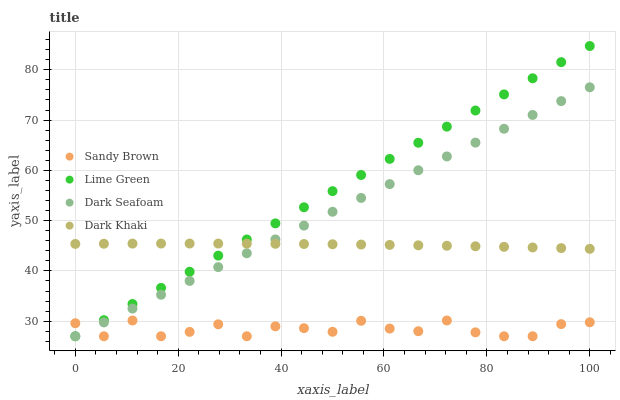Does Sandy Brown have the minimum area under the curve?
Answer yes or no. Yes. Does Lime Green have the maximum area under the curve?
Answer yes or no. Yes. Does Dark Seafoam have the minimum area under the curve?
Answer yes or no. No. Does Dark Seafoam have the maximum area under the curve?
Answer yes or no. No. Is Lime Green the smoothest?
Answer yes or no. Yes. Is Sandy Brown the roughest?
Answer yes or no. Yes. Is Dark Seafoam the smoothest?
Answer yes or no. No. Is Dark Seafoam the roughest?
Answer yes or no. No. Does Lime Green have the lowest value?
Answer yes or no. Yes. Does Lime Green have the highest value?
Answer yes or no. Yes. Does Dark Seafoam have the highest value?
Answer yes or no. No. Is Sandy Brown less than Dark Khaki?
Answer yes or no. Yes. Is Dark Khaki greater than Sandy Brown?
Answer yes or no. Yes. Does Lime Green intersect Sandy Brown?
Answer yes or no. Yes. Is Lime Green less than Sandy Brown?
Answer yes or no. No. Is Lime Green greater than Sandy Brown?
Answer yes or no. No. Does Sandy Brown intersect Dark Khaki?
Answer yes or no. No. 